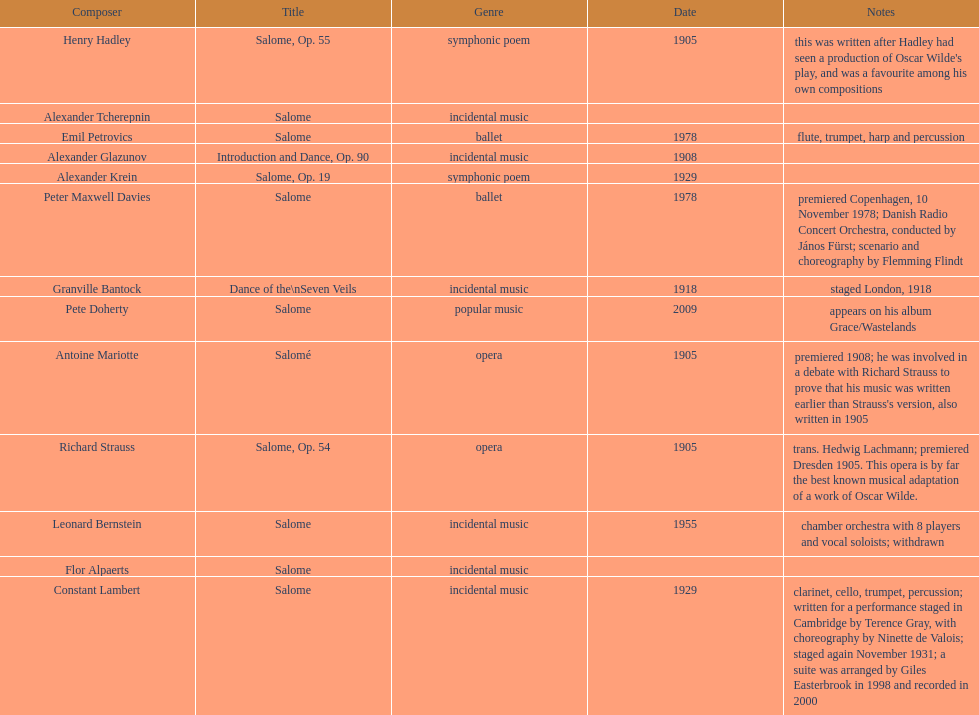Who is next on the list after alexander krein? Constant Lambert. 